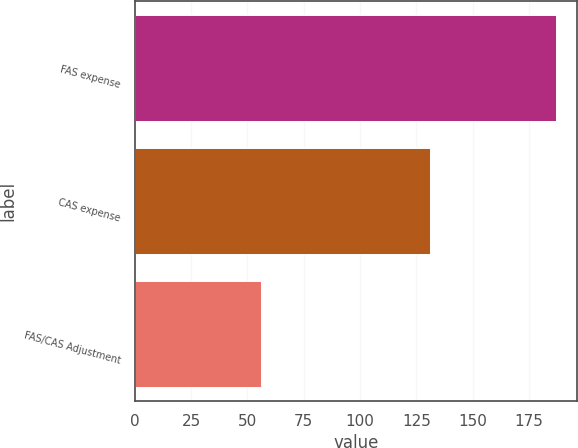Convert chart. <chart><loc_0><loc_0><loc_500><loc_500><bar_chart><fcel>FAS expense<fcel>CAS expense<fcel>FAS/CAS Adjustment<nl><fcel>187<fcel>131<fcel>56<nl></chart> 